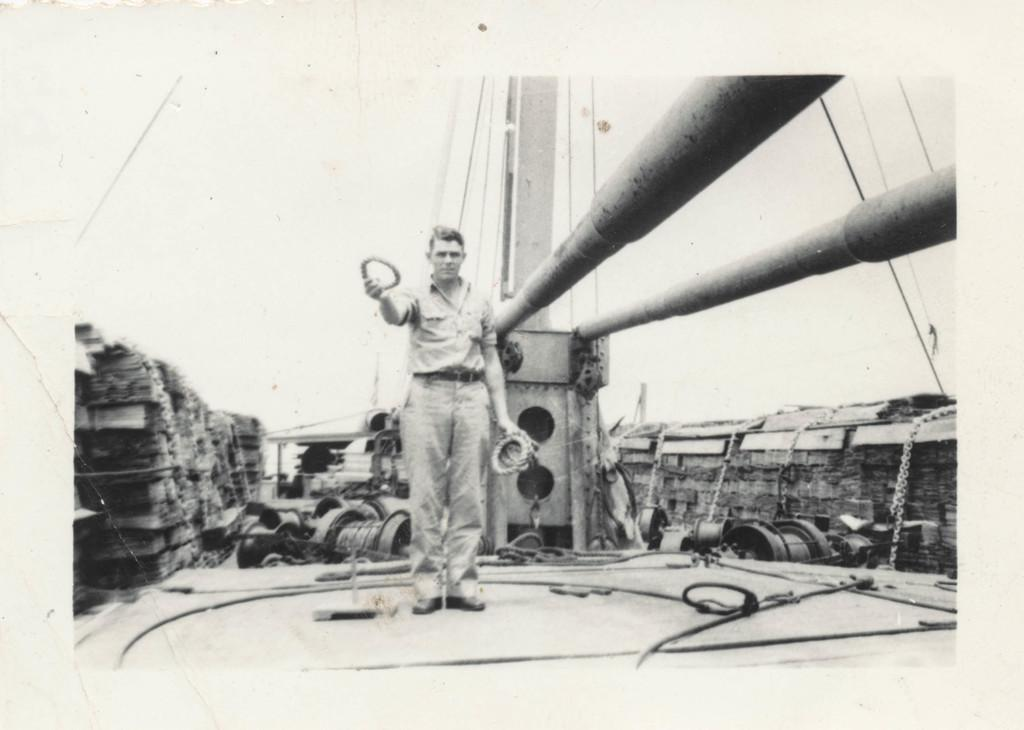What is the main subject of the image? There is a person standing in the image. What is the person holding in the image? The person is holding an object. What else can be seen in the image besides the person? There are poles and other objects visible in the image. What is the color scheme of the image? The image is in black and white. How many hands are visible on the cent in the image? There is no cent present in the image, so it is not possible to determine how many hands are visible on it. 